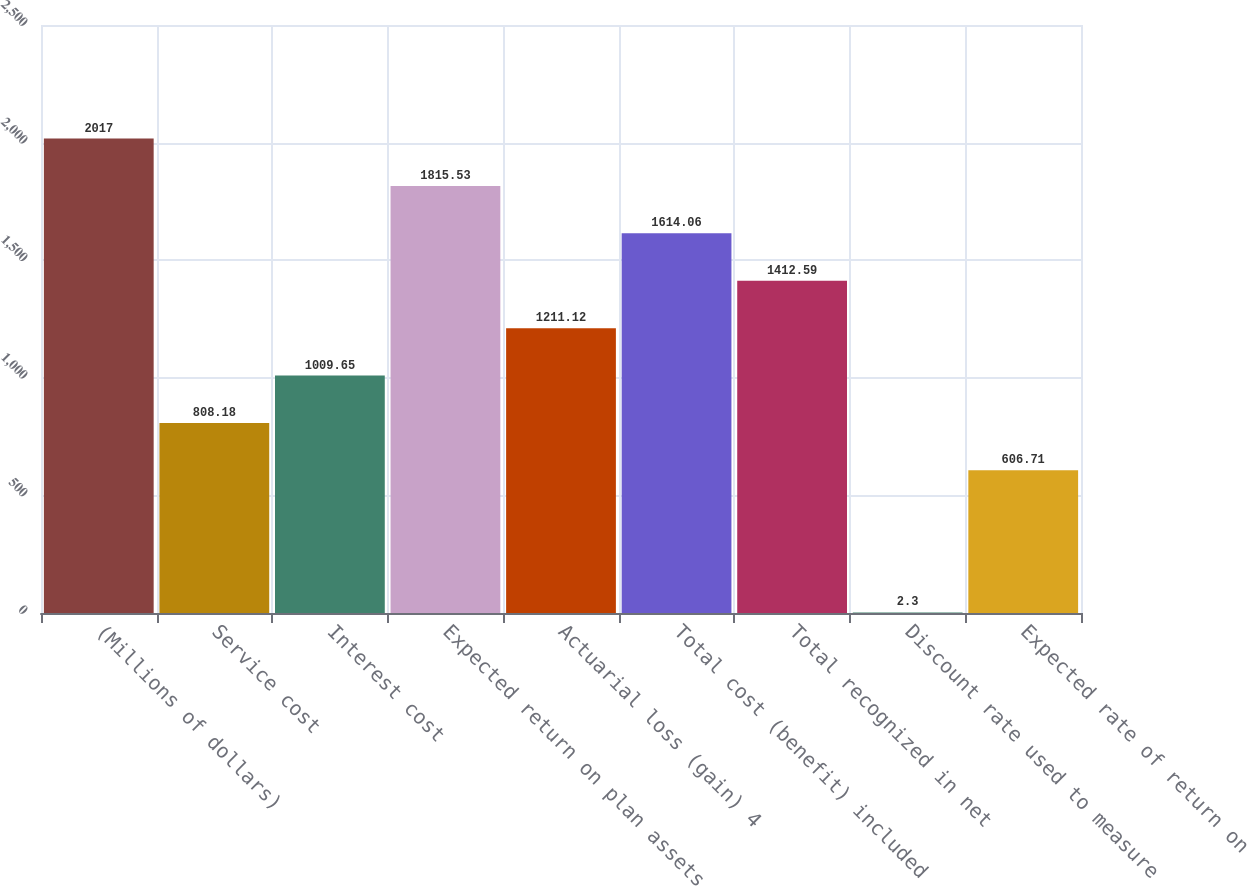Convert chart. <chart><loc_0><loc_0><loc_500><loc_500><bar_chart><fcel>(Millions of dollars)<fcel>Service cost<fcel>Interest cost<fcel>Expected return on plan assets<fcel>Actuarial loss (gain) 4<fcel>Total cost (benefit) included<fcel>Total recognized in net<fcel>Discount rate used to measure<fcel>Expected rate of return on<nl><fcel>2017<fcel>808.18<fcel>1009.65<fcel>1815.53<fcel>1211.12<fcel>1614.06<fcel>1412.59<fcel>2.3<fcel>606.71<nl></chart> 